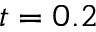Convert formula to latex. <formula><loc_0><loc_0><loc_500><loc_500>t = 0 . 2</formula> 